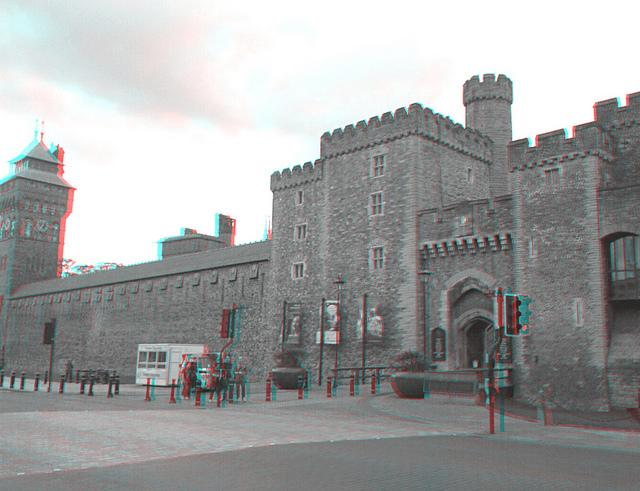What instance of building is shown in the image?

Choices:
A) tourist spot
B) government building
C) university
D) castle tourist spot 